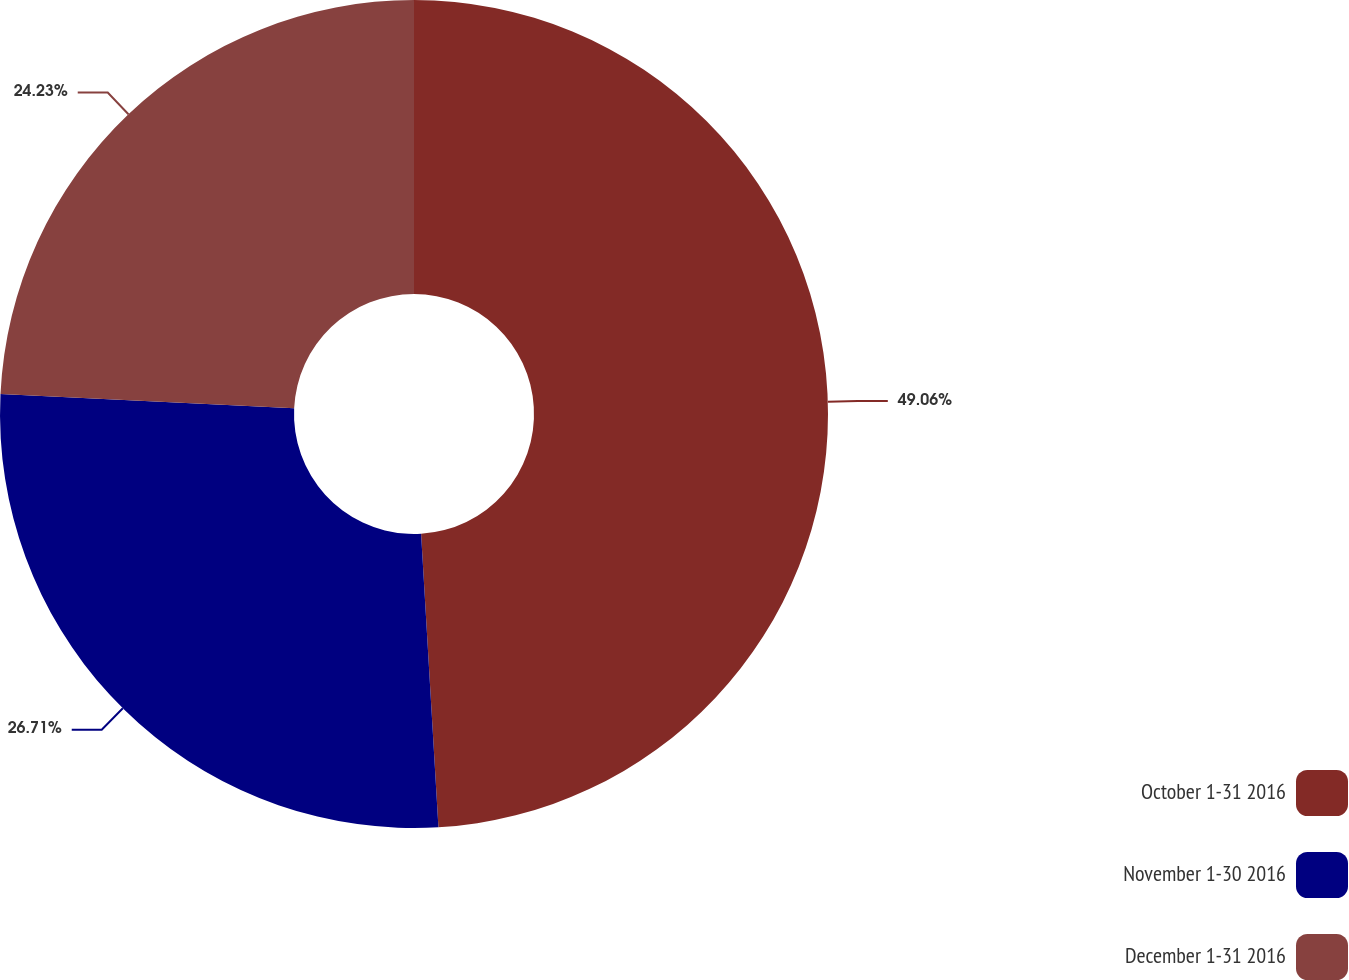Convert chart. <chart><loc_0><loc_0><loc_500><loc_500><pie_chart><fcel>October 1-31 2016<fcel>November 1-30 2016<fcel>December 1-31 2016<nl><fcel>49.06%<fcel>26.71%<fcel>24.23%<nl></chart> 